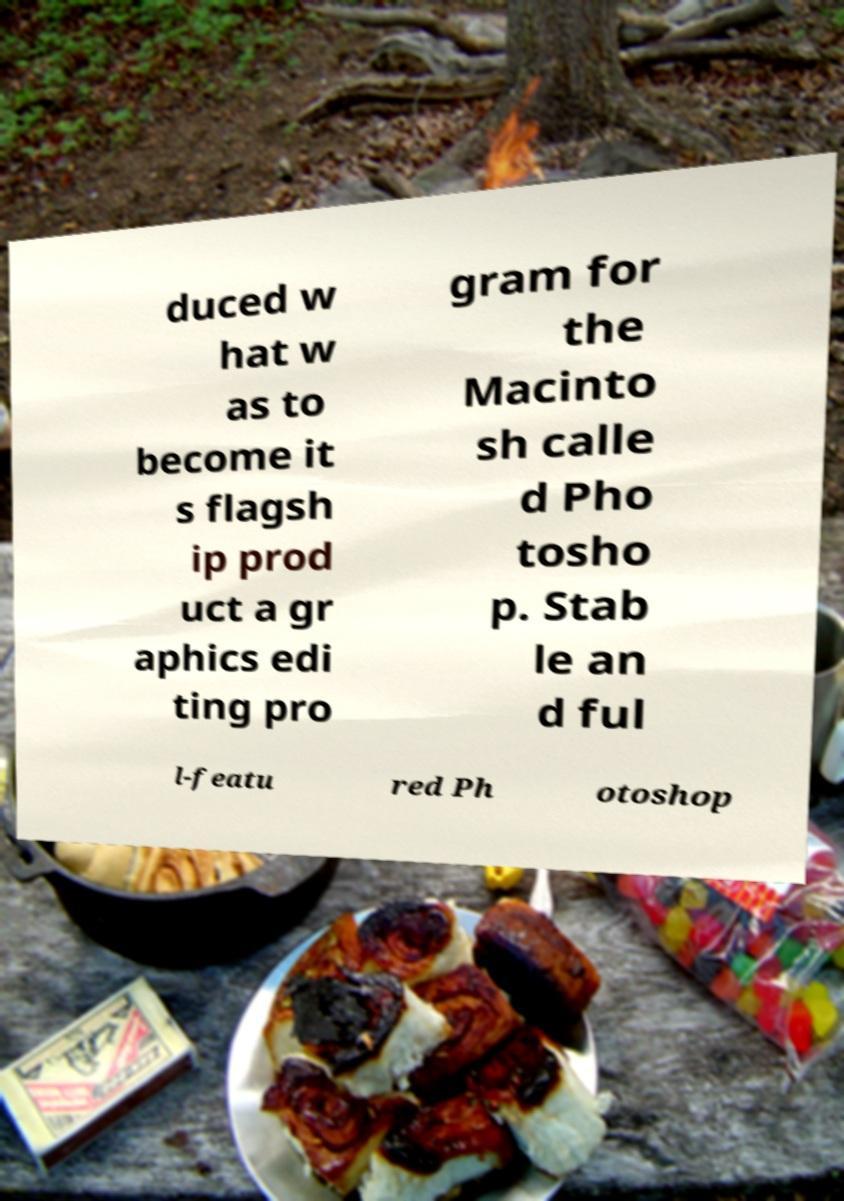Please read and relay the text visible in this image. What does it say? duced w hat w as to become it s flagsh ip prod uct a gr aphics edi ting pro gram for the Macinto sh calle d Pho tosho p. Stab le an d ful l-featu red Ph otoshop 